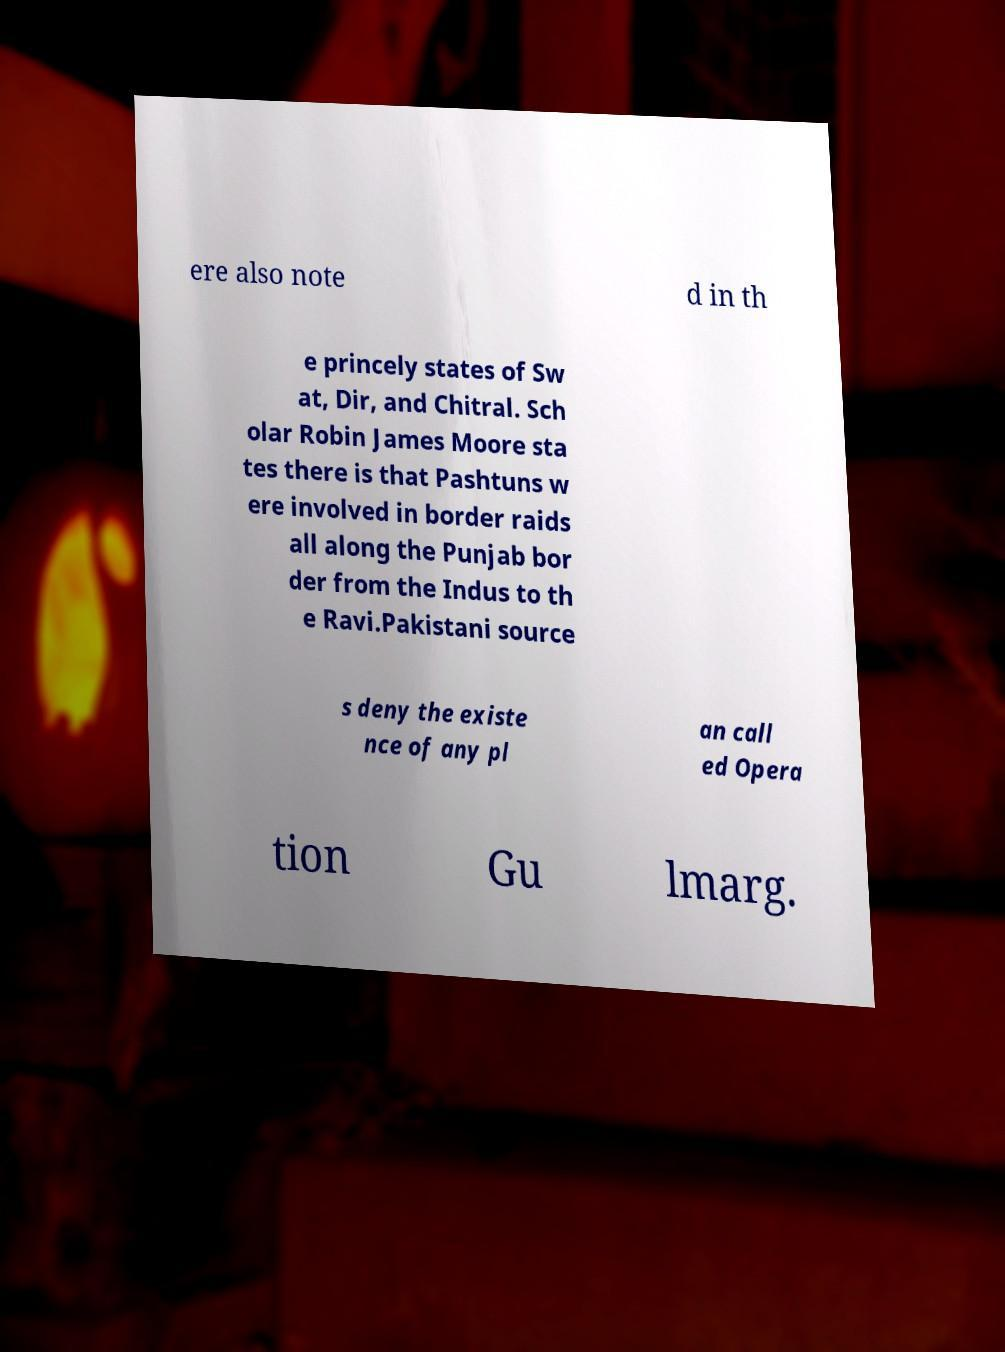What messages or text are displayed in this image? I need them in a readable, typed format. ere also note d in th e princely states of Sw at, Dir, and Chitral. Sch olar Robin James Moore sta tes there is that Pashtuns w ere involved in border raids all along the Punjab bor der from the Indus to th e Ravi.Pakistani source s deny the existe nce of any pl an call ed Opera tion Gu lmarg. 